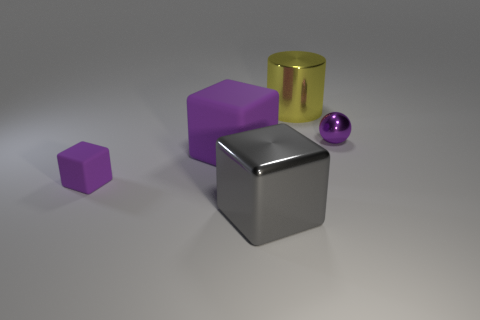The metallic thing that is the same color as the large rubber object is what shape?
Keep it short and to the point. Sphere. There is a gray block that is the same size as the yellow shiny cylinder; what material is it?
Ensure brevity in your answer.  Metal. There is a large object that is right of the gray metallic cube; is it the same shape as the large matte thing?
Offer a very short reply. No. Is the number of purple things that are behind the tiny purple rubber cube greater than the number of big purple cubes to the right of the gray cube?
Ensure brevity in your answer.  Yes. How many purple spheres are the same material as the yellow object?
Offer a terse response. 1. Do the cylinder and the gray metal thing have the same size?
Give a very brief answer. Yes. What color is the sphere?
Keep it short and to the point. Purple. How many things are matte cubes or shiny balls?
Offer a terse response. 3. Is there a tiny purple metallic thing that has the same shape as the big purple rubber thing?
Your answer should be compact. No. Is the color of the large metal object that is left of the metal cylinder the same as the small ball?
Provide a succinct answer. No. 